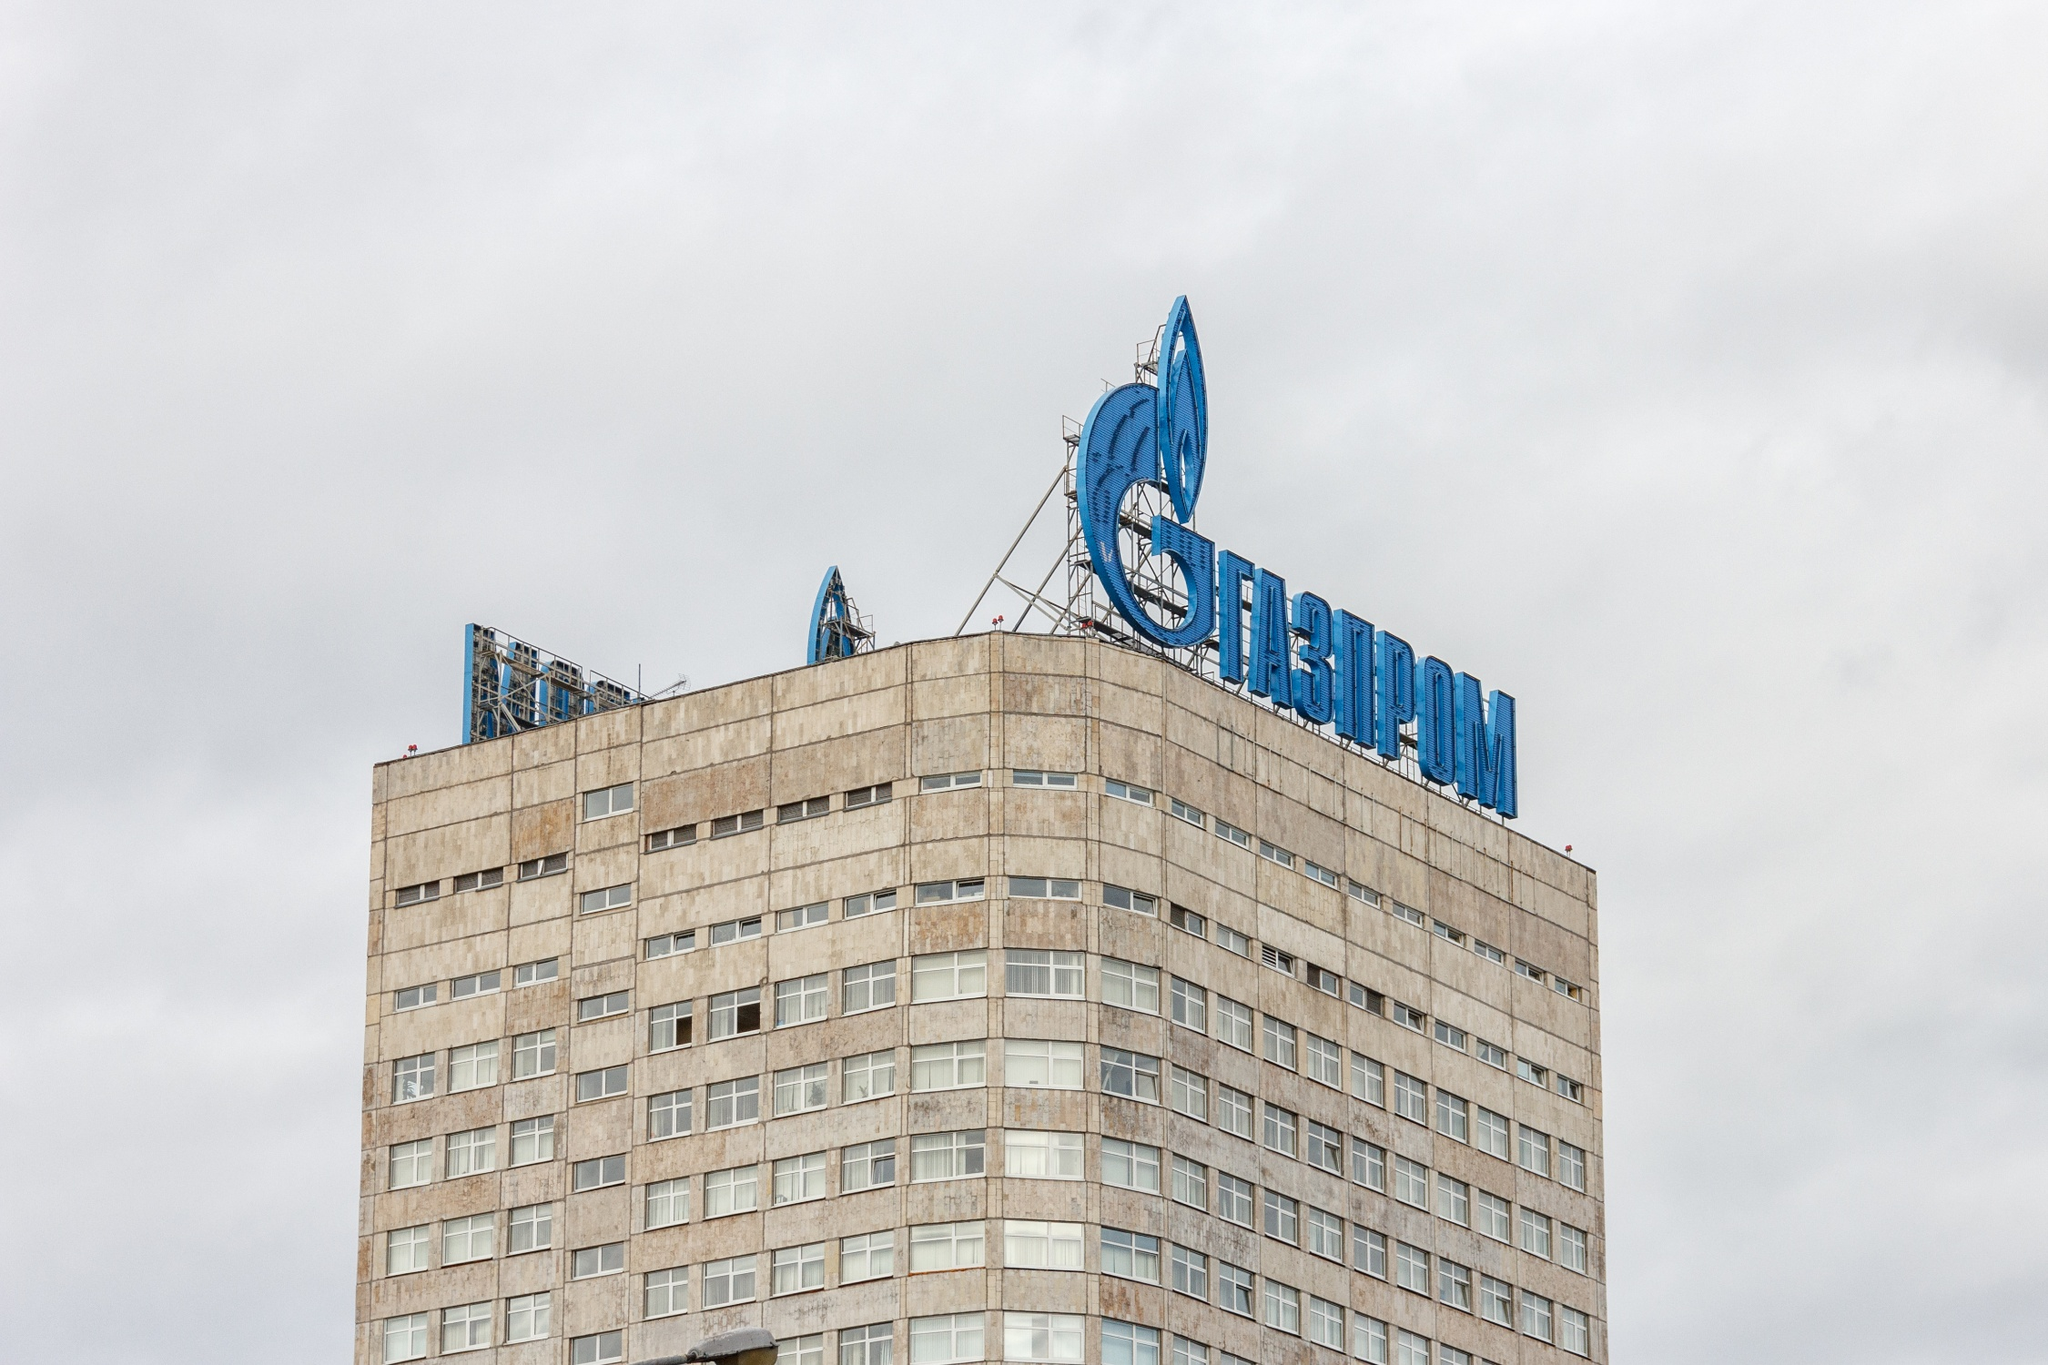What do the architectural styles tell us about the evolution of corporate buildings in urban landscapes? The architectural style of the Gazprom headquarters illustrates the evolution of corporate buildings towards a blend of functionality, aesthetics, and corporate identity. The modern, sleek structure reflects a departure from traditional, utilitarian designs, embracing a more bold and recognizable form. The use of large, imposing facades and prominent logos speaks to the desire for corporate visibility and dominance in the urban landscape. This evolution signifies a shift from mere office space to architectural statements, where buildings not only serve as workplaces but also embody the brand's values and aspirations. What does the logo placement on the building signify? The prominent placement of the Gazprom logo at the pinnacle of the building signifies the company’s desire for high visibility and command in the urban skyline. It communicates Gazprom's significant influence and leadership in the energy sector, asserting its presence and identity amidst the city's panorama. The elevated position of the logo also reflects the company's ambition and aspiration to stand above, symbolically reaching for the heights of success and innovation. What might be the symbolic meaning of the flame in Gazprom's logo? The flame in Gazprom's logo is symbolic on multiple levels. Primarily, it represents energy and power, core elements of the company’s mission and operations. The blue flame is often associated with natural gas, indicative of Gazprom’s major role in the gas industry. Symbolically, fire represents transformation, innovation, and movement—a nod to the company’s commitment to cutting-edge technology and progress. Additionally, flame is a universal symbol of life and sustainability, echoing Gazprom’s impact on fueling industries and homes globally. If this building could interact with other iconic buildings in Moscow, what conversation might unfold? In an imaginative scenario where buildings converse, the Gazprom headquarters might engage with the likes of St. Basil's Cathedral and the Kremlin. The Gazprom building, with its modern and sleek lines, might proudly declare, 'I symbolize the future of energy and economic progress.' St. Basil's Cathedral, with its colorful and ornate domes, might respond, 'I am a testament to the artistic heritage and resilient spirit of our people.' The Kremlin might interject, 'I embody the power, history, and governance that have shaped our nation.' Together, these icons would discuss the evolving narrative of Moscow, blending tradition, governance, and modernity in a rich tapestry of architectural dialogue. 